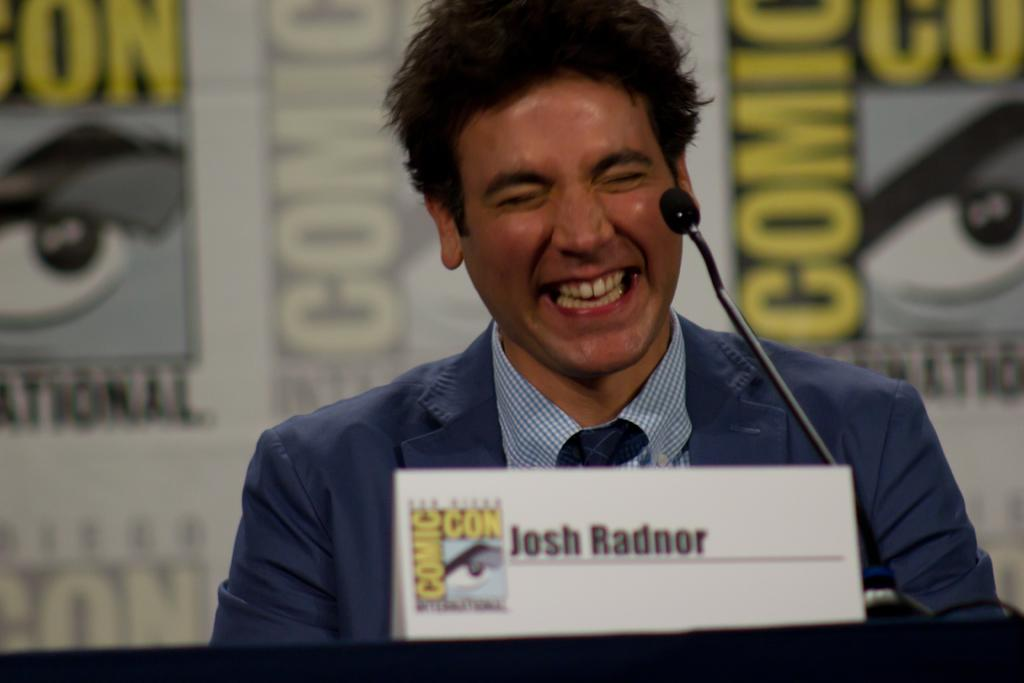What is the person in the image doing? The person is seated on a chair in the image. How does the person appear to be feeling? The person has a smile on their face, indicating a positive or happy emotion. What object is in front of the person? There is a mic in front of the person. What is placed on the floor in front of the person? There is a name board in front of the person. What can be seen behind the person? There is a banner behind the person. Reasoning: Let's think step by step in the image. We start by describing the main subject, which is the person seated on a chair. Then, we mention the person's facial expression, noting that they have a smile on their face. Next, we identify the objects in front of and behind the person, such as the mic, name board, and banner. Each question is designed to elicit a specific detail about the image that is known from the provided facts. Absurd Question/Answer: What type of mouthwash is the person using in the image? There is no mouthwash present in the image; the person has a smile on their face. How many cacti are visible behind the person in the image? There are no cacti visible in the image; there is a banner behind the person. What type of bag is the person holding in the image? There is no bag present in the image; the person is seated on a chair with a mic, name board, and banner visible. 